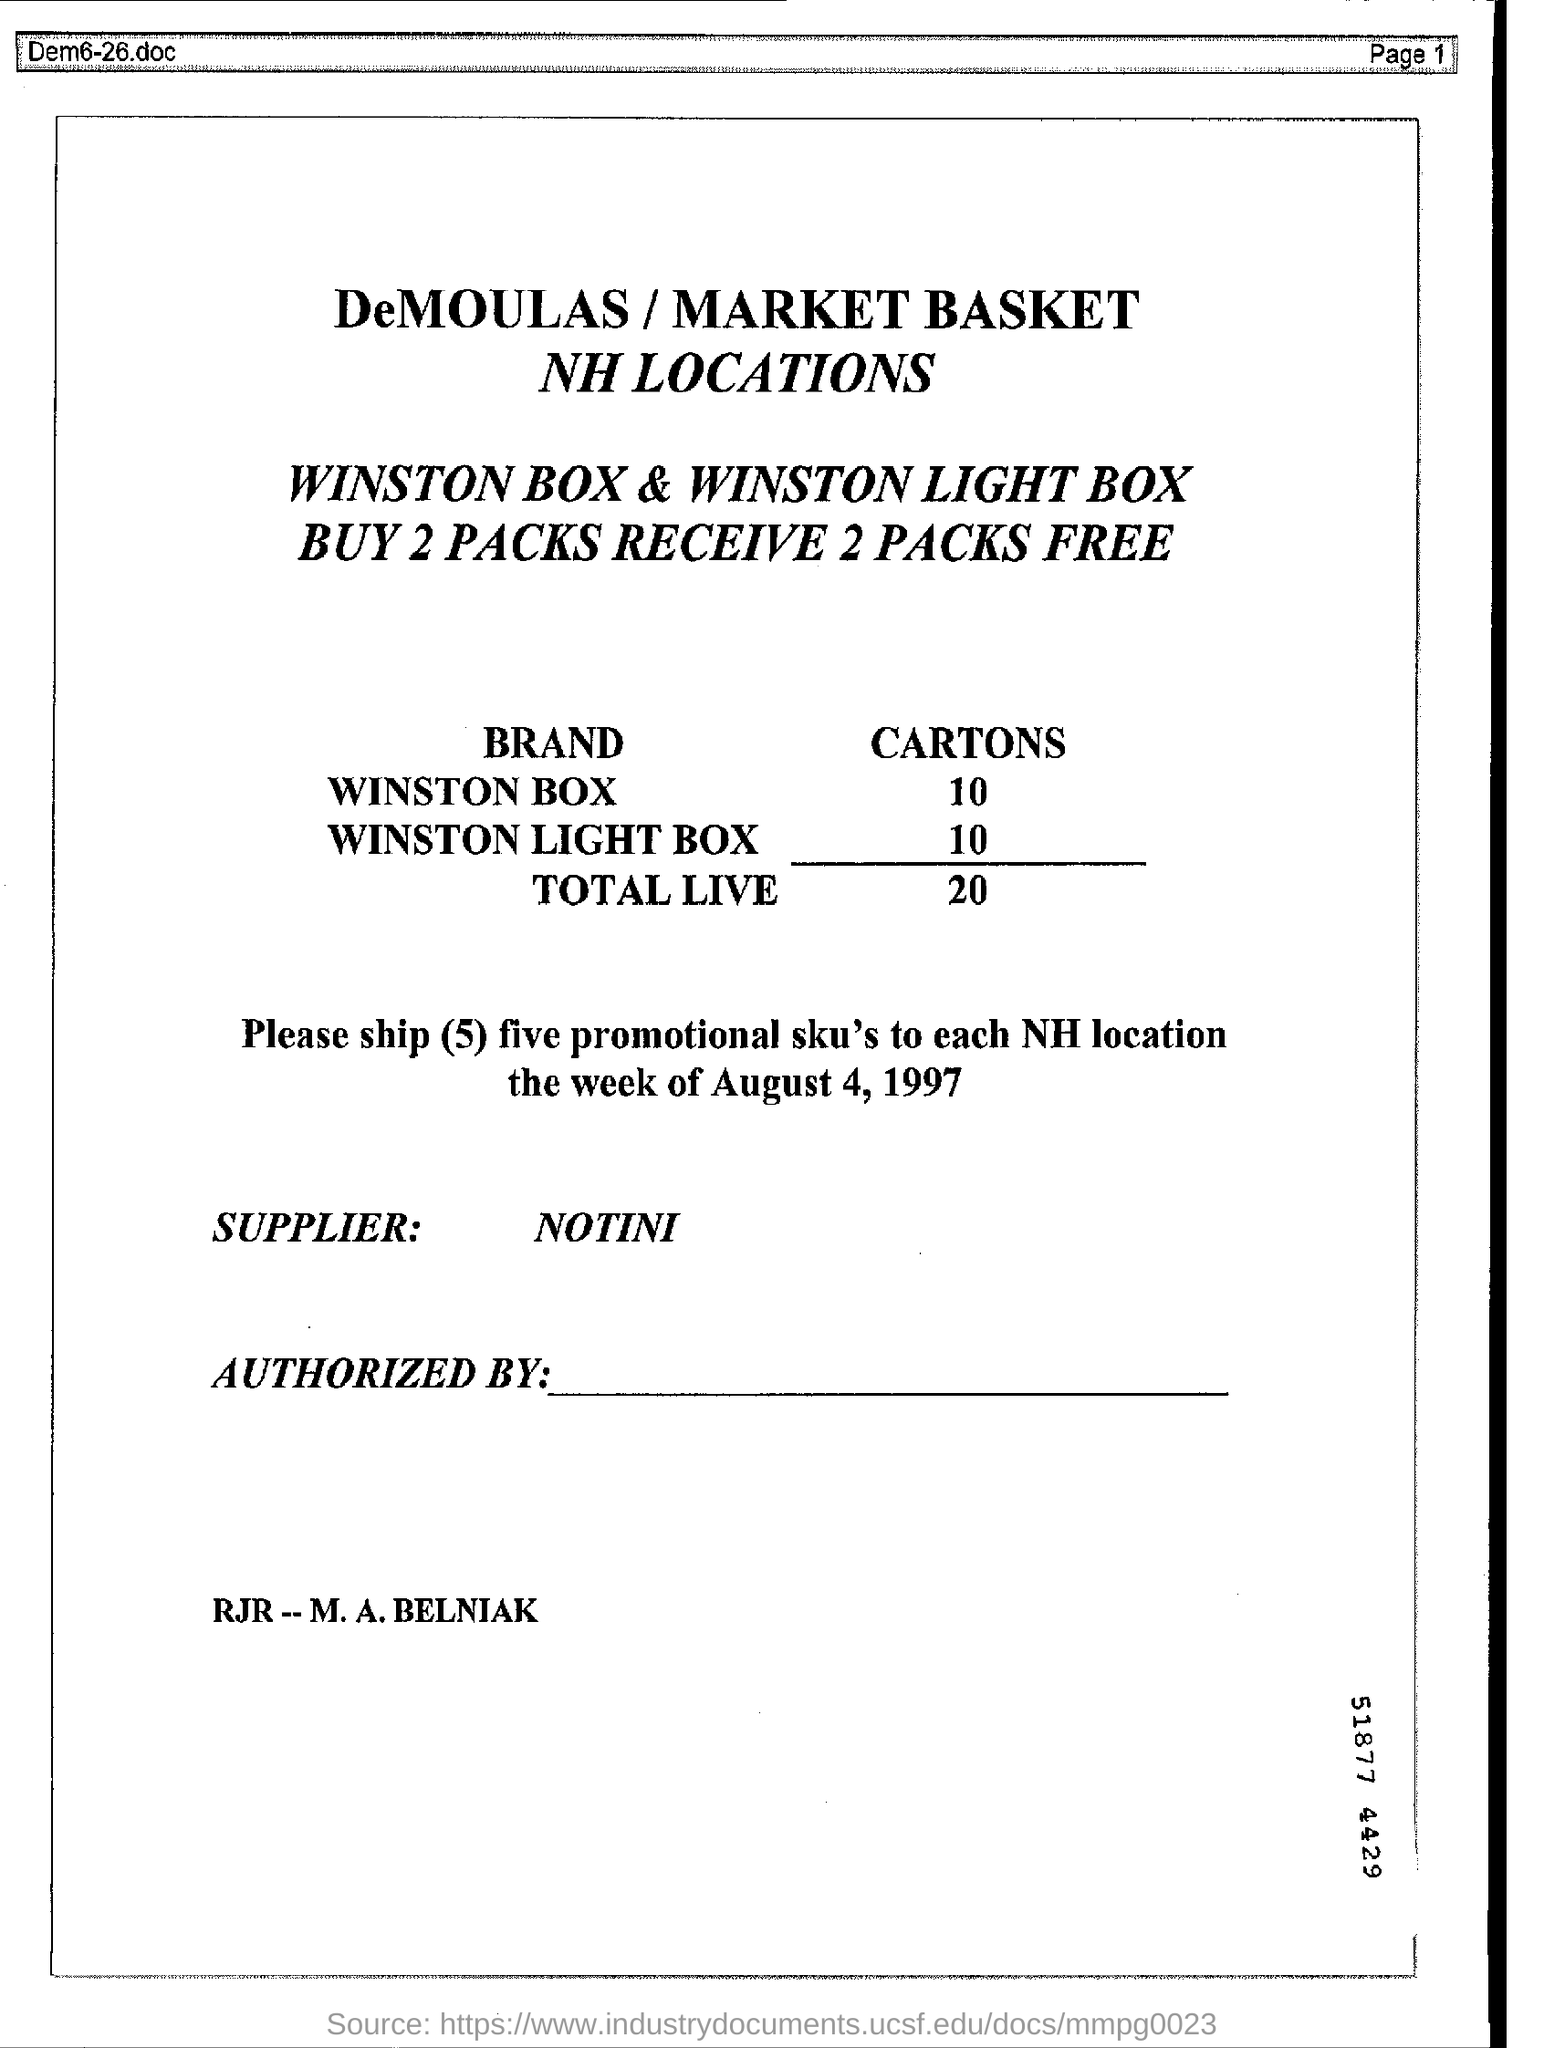Number of cartons of WINSTON BOX ?
Ensure brevity in your answer.  10. Number of cartons of WINSTON LIGHT BOX ?
Offer a terse response. 10. Who is the supplier ?
Your answer should be compact. NOTINI. 